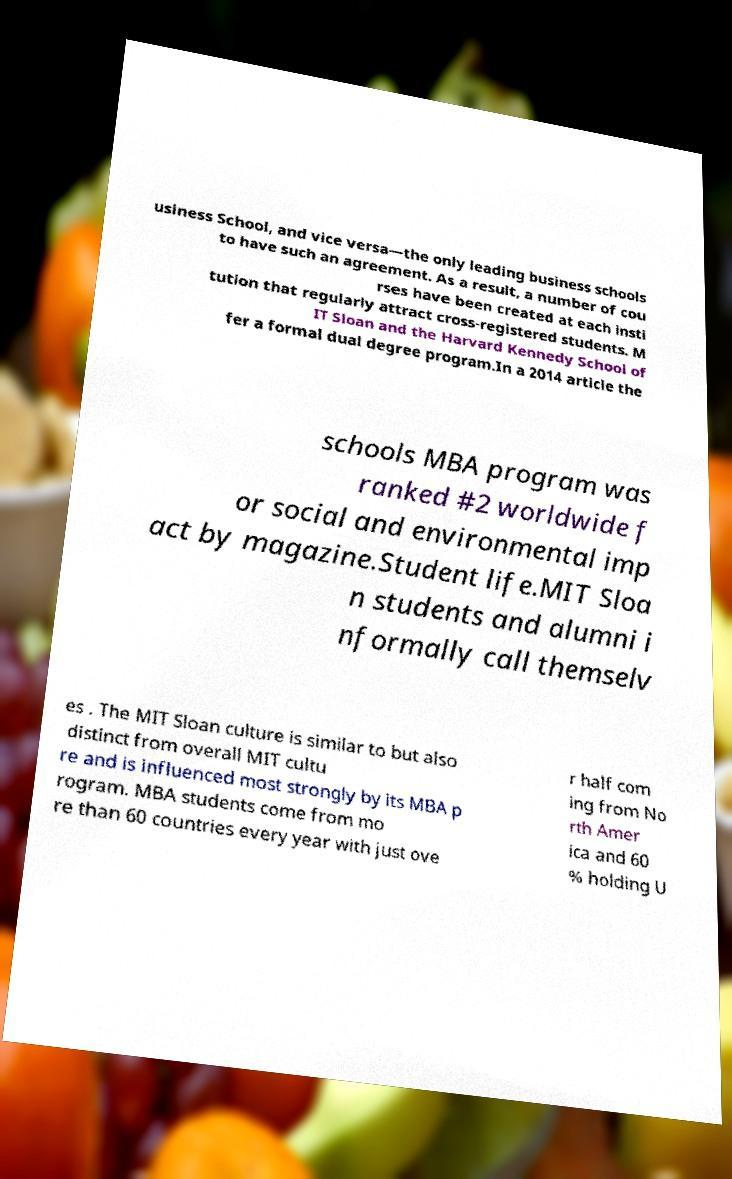What messages or text are displayed in this image? I need them in a readable, typed format. usiness School, and vice versa—the only leading business schools to have such an agreement. As a result, a number of cou rses have been created at each insti tution that regularly attract cross-registered students. M IT Sloan and the Harvard Kennedy School of fer a formal dual degree program.In a 2014 article the schools MBA program was ranked #2 worldwide f or social and environmental imp act by magazine.Student life.MIT Sloa n students and alumni i nformally call themselv es . The MIT Sloan culture is similar to but also distinct from overall MIT cultu re and is influenced most strongly by its MBA p rogram. MBA students come from mo re than 60 countries every year with just ove r half com ing from No rth Amer ica and 60 % holding U 